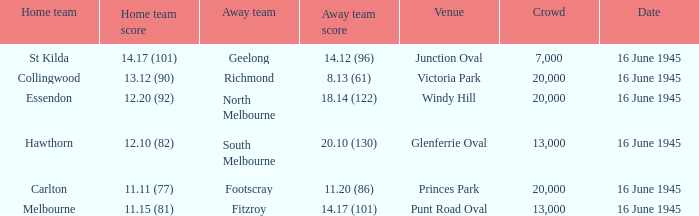What was the Home team score for the team that played South Melbourne? 12.10 (82). 